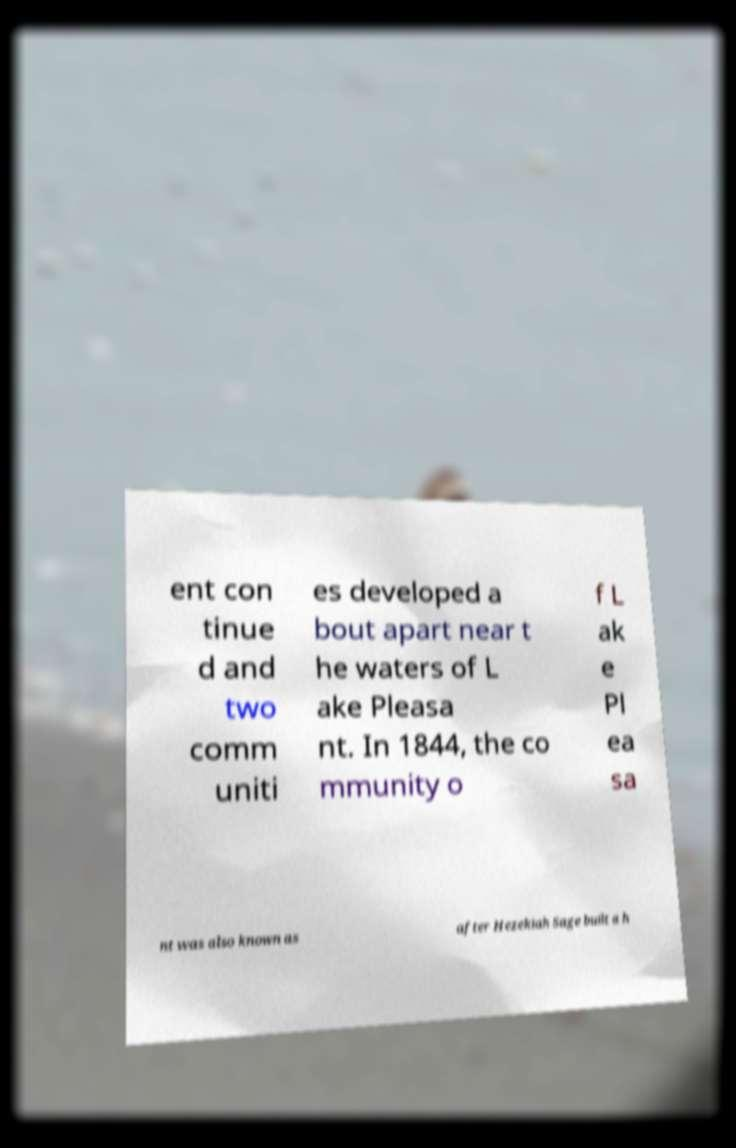I need the written content from this picture converted into text. Can you do that? ent con tinue d and two comm uniti es developed a bout apart near t he waters of L ake Pleasa nt. In 1844, the co mmunity o f L ak e Pl ea sa nt was also known as after Hezekiah Sage built a h 